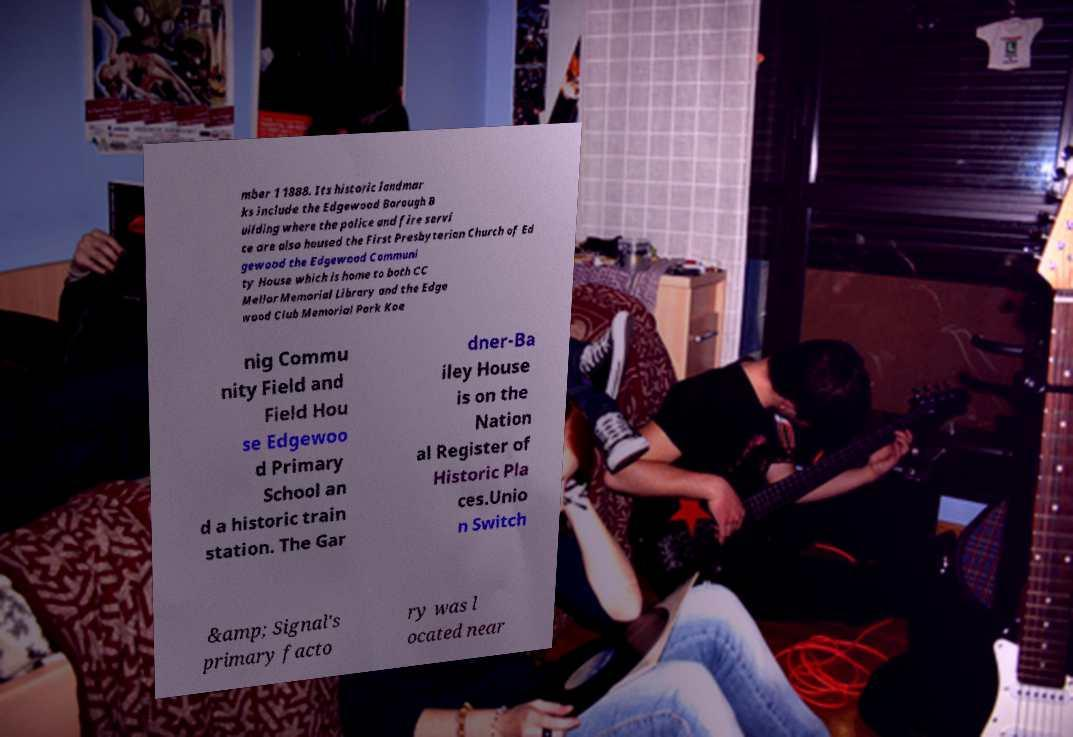I need the written content from this picture converted into text. Can you do that? mber 1 1888. Its historic landmar ks include the Edgewood Borough B uilding where the police and fire servi ce are also housed the First Presbyterian Church of Ed gewood the Edgewood Communi ty House which is home to both CC Mellor Memorial Library and the Edge wood Club Memorial Park Koe nig Commu nity Field and Field Hou se Edgewoo d Primary School an d a historic train station. The Gar dner-Ba iley House is on the Nation al Register of Historic Pla ces.Unio n Switch &amp; Signal's primary facto ry was l ocated near 